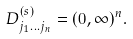<formula> <loc_0><loc_0><loc_500><loc_500>{ D } _ { j _ { 1 } \dots j _ { n } } ^ { ( s ) } = ( 0 , \infty ) ^ { n } .</formula> 